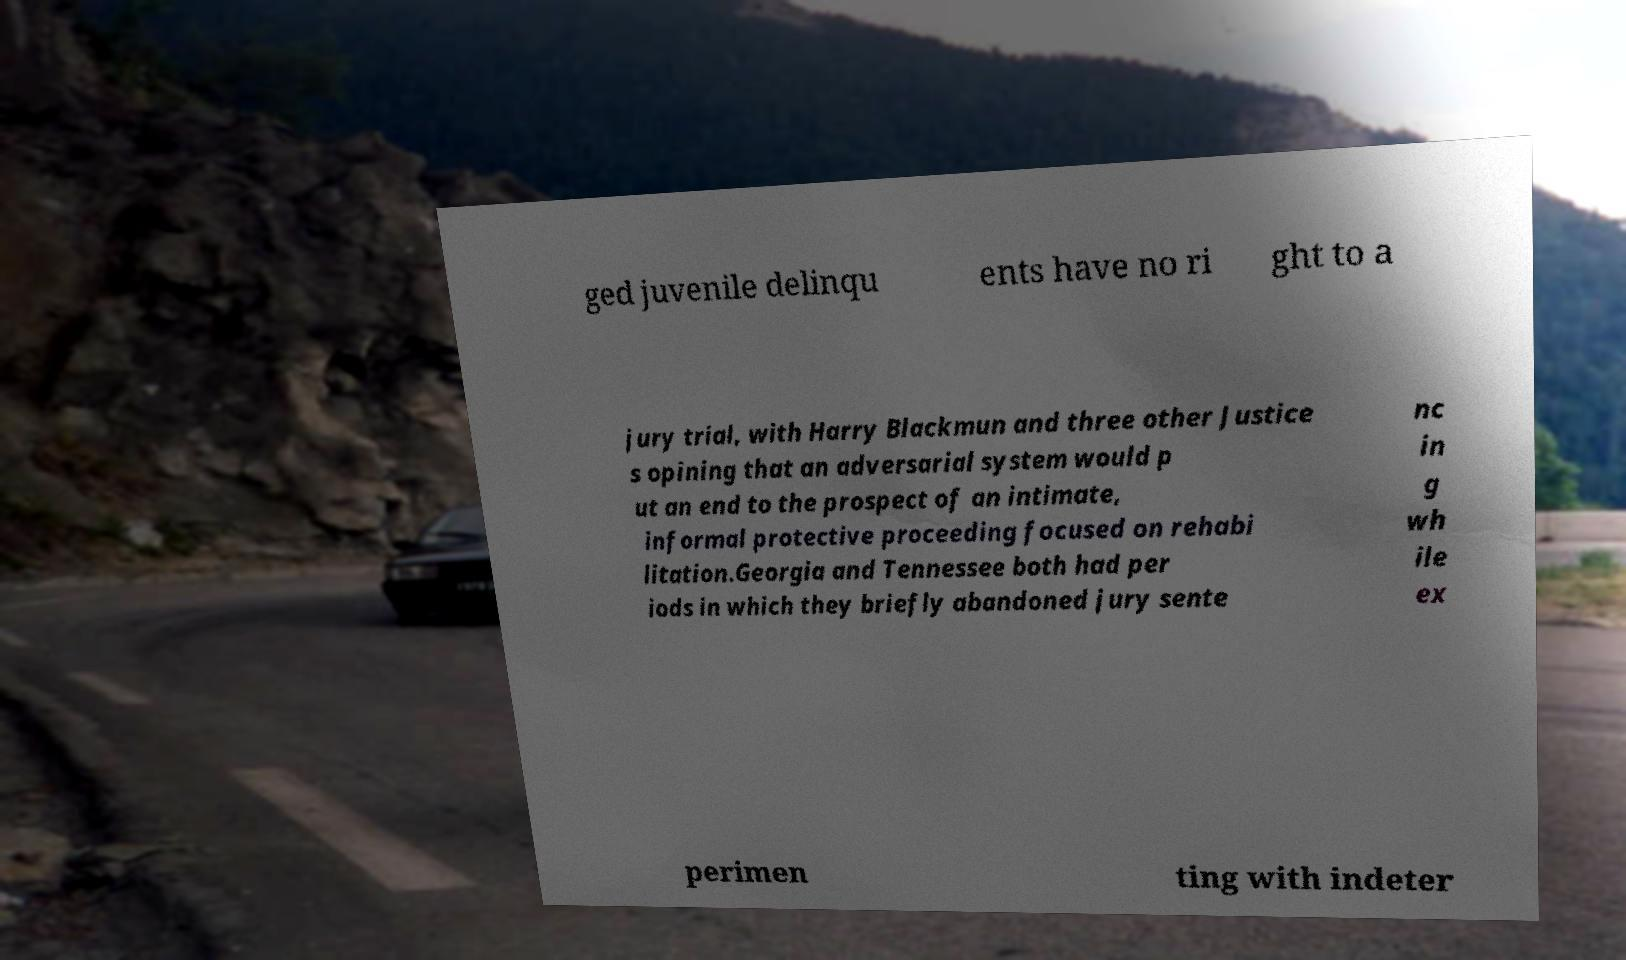Please identify and transcribe the text found in this image. ged juvenile delinqu ents have no ri ght to a jury trial, with Harry Blackmun and three other Justice s opining that an adversarial system would p ut an end to the prospect of an intimate, informal protective proceeding focused on rehabi litation.Georgia and Tennessee both had per iods in which they briefly abandoned jury sente nc in g wh ile ex perimen ting with indeter 